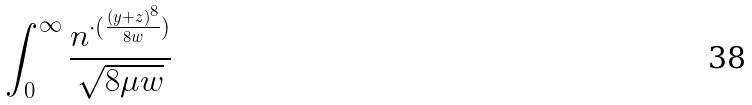<formula> <loc_0><loc_0><loc_500><loc_500>\int _ { 0 } ^ { \infty } \frac { n ^ { \cdot ( \frac { ( y + z ) ^ { 8 } } { 8 w } ) } } { \sqrt { 8 \mu w } }</formula> 